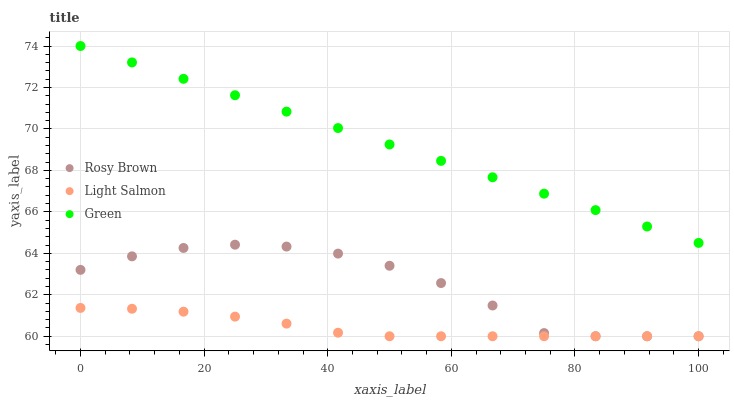Does Light Salmon have the minimum area under the curve?
Answer yes or no. Yes. Does Green have the maximum area under the curve?
Answer yes or no. Yes. Does Rosy Brown have the minimum area under the curve?
Answer yes or no. No. Does Rosy Brown have the maximum area under the curve?
Answer yes or no. No. Is Green the smoothest?
Answer yes or no. Yes. Is Rosy Brown the roughest?
Answer yes or no. Yes. Is Rosy Brown the smoothest?
Answer yes or no. No. Is Green the roughest?
Answer yes or no. No. Does Light Salmon have the lowest value?
Answer yes or no. Yes. Does Green have the lowest value?
Answer yes or no. No. Does Green have the highest value?
Answer yes or no. Yes. Does Rosy Brown have the highest value?
Answer yes or no. No. Is Rosy Brown less than Green?
Answer yes or no. Yes. Is Green greater than Rosy Brown?
Answer yes or no. Yes. Does Light Salmon intersect Rosy Brown?
Answer yes or no. Yes. Is Light Salmon less than Rosy Brown?
Answer yes or no. No. Is Light Salmon greater than Rosy Brown?
Answer yes or no. No. Does Rosy Brown intersect Green?
Answer yes or no. No. 